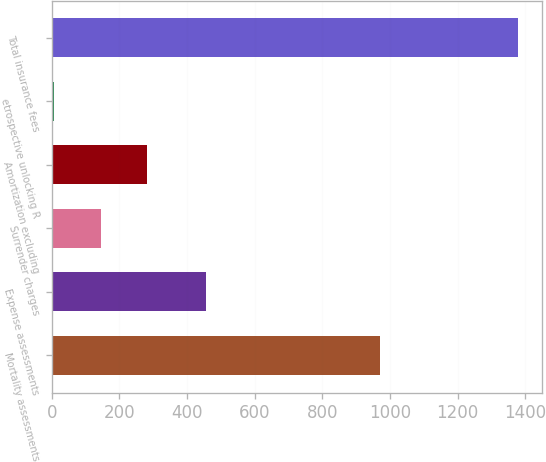<chart> <loc_0><loc_0><loc_500><loc_500><bar_chart><fcel>Mortality assessments<fcel>Expense assessments<fcel>Surrender charges<fcel>Amortization excluding<fcel>etrospective unlocking R<fcel>Total insurance fees<nl><fcel>970<fcel>457<fcel>144.3<fcel>281.6<fcel>7<fcel>1380<nl></chart> 